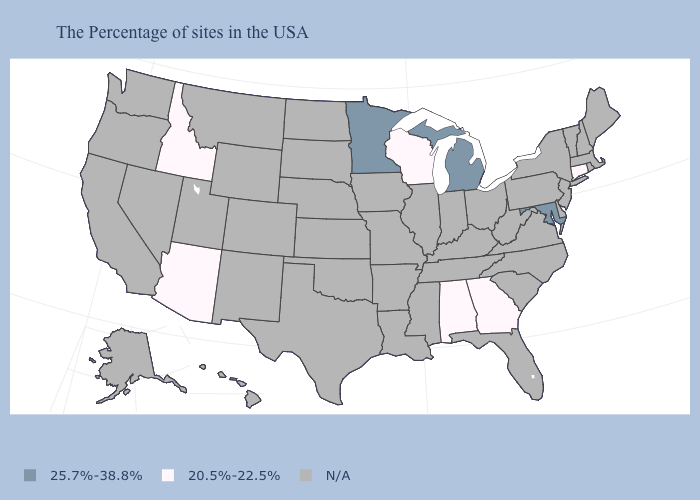Name the states that have a value in the range N/A?
Answer briefly. Maine, Massachusetts, Rhode Island, New Hampshire, Vermont, New York, New Jersey, Delaware, Pennsylvania, Virginia, North Carolina, South Carolina, West Virginia, Ohio, Florida, Kentucky, Indiana, Tennessee, Illinois, Mississippi, Louisiana, Missouri, Arkansas, Iowa, Kansas, Nebraska, Oklahoma, Texas, South Dakota, North Dakota, Wyoming, Colorado, New Mexico, Utah, Montana, Nevada, California, Washington, Oregon, Alaska, Hawaii. Does the first symbol in the legend represent the smallest category?
Write a very short answer. No. Which states hav the highest value in the MidWest?
Answer briefly. Michigan, Minnesota. What is the highest value in the West ?
Write a very short answer. 20.5%-22.5%. Does Minnesota have the lowest value in the USA?
Keep it brief. No. Does Minnesota have the lowest value in the USA?
Concise answer only. No. What is the lowest value in states that border Indiana?
Short answer required. 25.7%-38.8%. What is the lowest value in the USA?
Concise answer only. 20.5%-22.5%. Name the states that have a value in the range 25.7%-38.8%?
Give a very brief answer. Maryland, Michigan, Minnesota. Name the states that have a value in the range 20.5%-22.5%?
Concise answer only. Connecticut, Georgia, Alabama, Wisconsin, Arizona, Idaho. Name the states that have a value in the range N/A?
Quick response, please. Maine, Massachusetts, Rhode Island, New Hampshire, Vermont, New York, New Jersey, Delaware, Pennsylvania, Virginia, North Carolina, South Carolina, West Virginia, Ohio, Florida, Kentucky, Indiana, Tennessee, Illinois, Mississippi, Louisiana, Missouri, Arkansas, Iowa, Kansas, Nebraska, Oklahoma, Texas, South Dakota, North Dakota, Wyoming, Colorado, New Mexico, Utah, Montana, Nevada, California, Washington, Oregon, Alaska, Hawaii. Name the states that have a value in the range N/A?
Be succinct. Maine, Massachusetts, Rhode Island, New Hampshire, Vermont, New York, New Jersey, Delaware, Pennsylvania, Virginia, North Carolina, South Carolina, West Virginia, Ohio, Florida, Kentucky, Indiana, Tennessee, Illinois, Mississippi, Louisiana, Missouri, Arkansas, Iowa, Kansas, Nebraska, Oklahoma, Texas, South Dakota, North Dakota, Wyoming, Colorado, New Mexico, Utah, Montana, Nevada, California, Washington, Oregon, Alaska, Hawaii. 